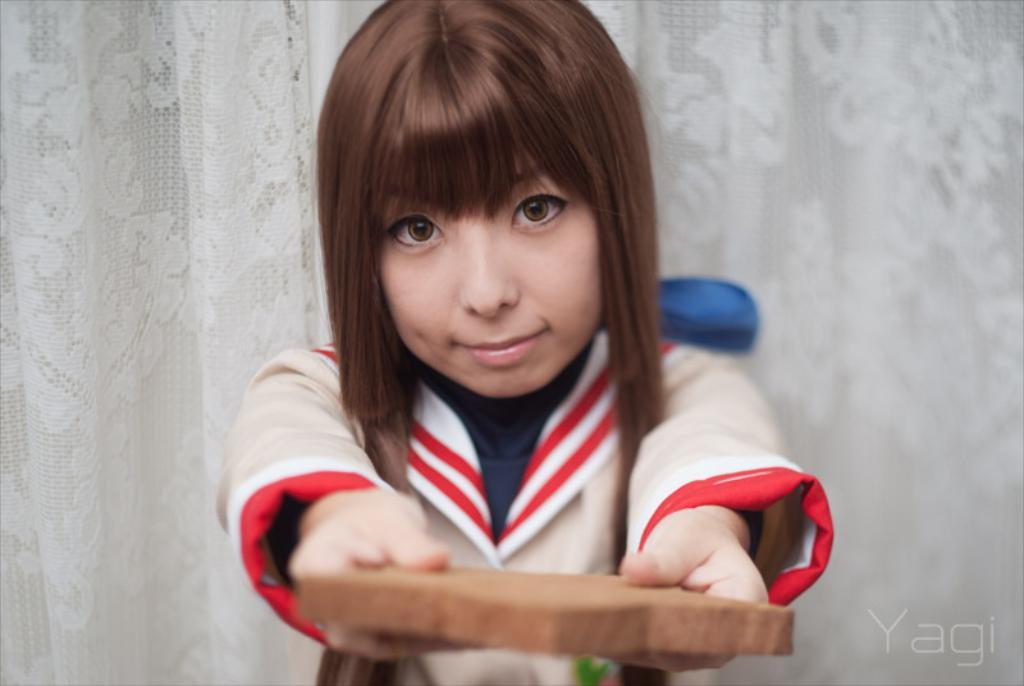Who is the main subject in the image? There is a woman in the image. What is the woman's facial expression? The woman is smiling. What is the woman holding in the image? The woman is holding an object. What can be seen in the background of the image? There is a white curtain in the background of the image. Is there any additional information about the image itself? Yes, there is a watermark on the right side bottom of the image. How does the woman stretch her arms in the image? The image does not show the woman stretching her arms; she is holding an object. What is the relationship between the woman and the person in the image? The image does not show another person, so it is impossible to determine the relationship between the woman and anyone else. 